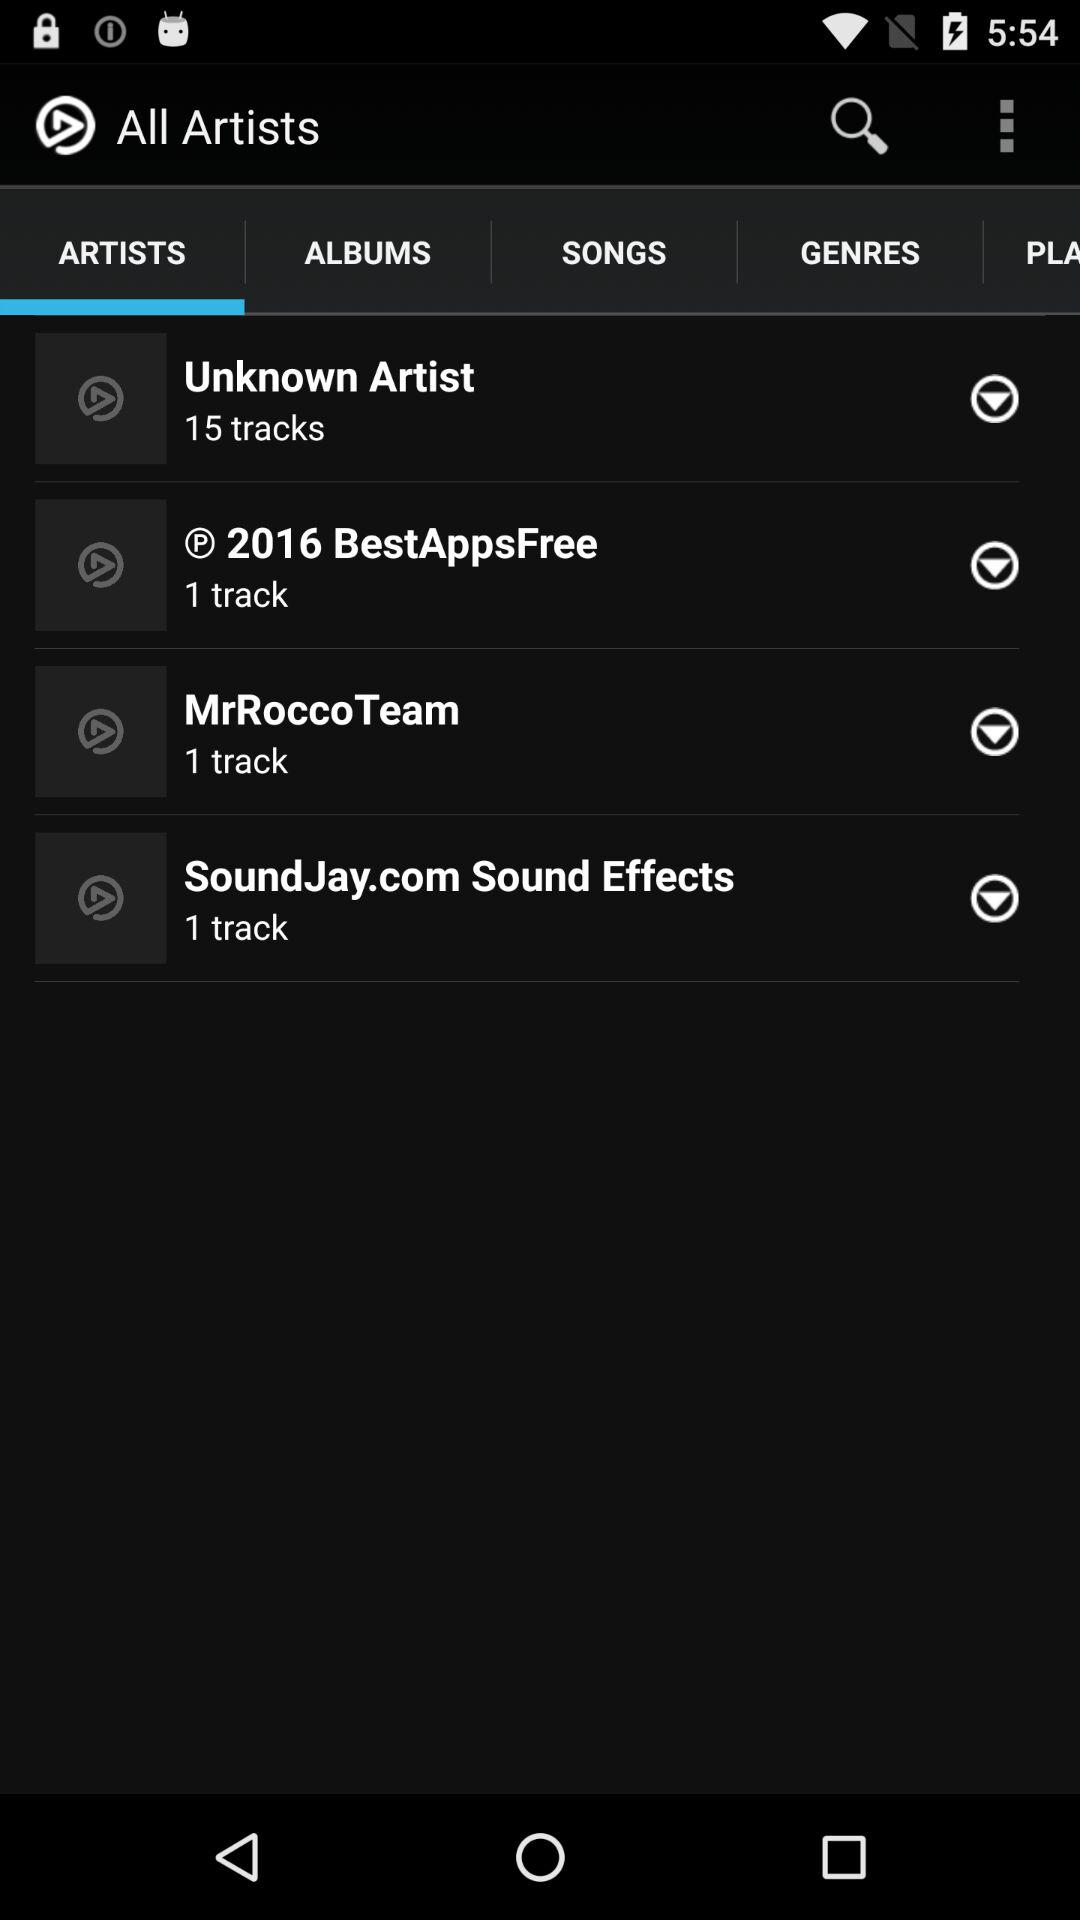How many songs are there in "Unknown Artist" playlist? There are 15 songs. 